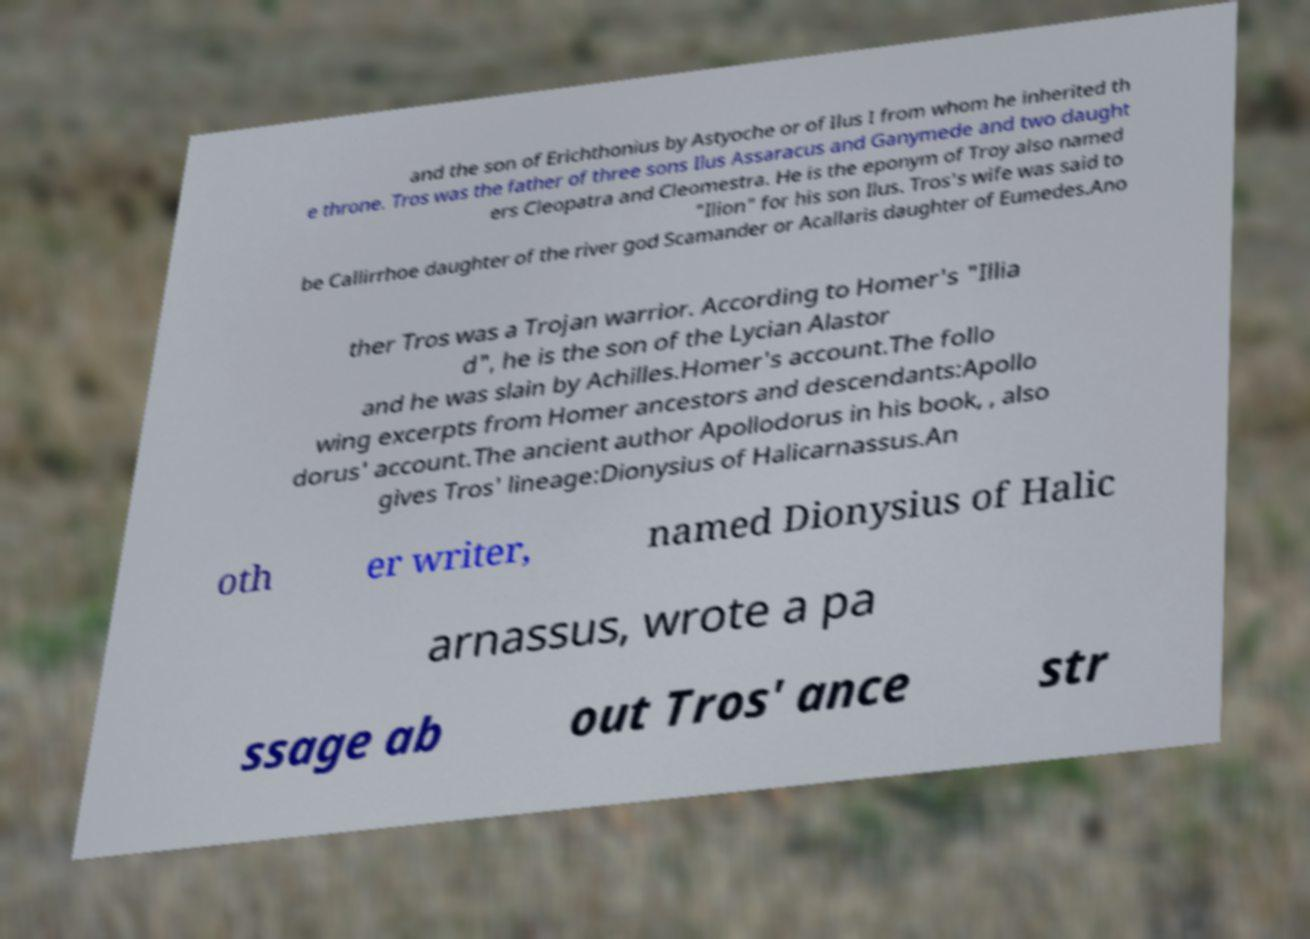Please read and relay the text visible in this image. What does it say? and the son of Erichthonius by Astyoche or of Ilus I from whom he inherited th e throne. Tros was the father of three sons Ilus Assaracus and Ganymede and two daught ers Cleopatra and Cleomestra. He is the eponym of Troy also named "Ilion" for his son Ilus. Tros's wife was said to be Callirrhoe daughter of the river god Scamander or Acallaris daughter of Eumedes.Ano ther Tros was a Trojan warrior. According to Homer's "Illia d", he is the son of the Lycian Alastor and he was slain by Achilles.Homer's account.The follo wing excerpts from Homer ancestors and descendants:Apollo dorus' account.The ancient author Apollodorus in his book, , also gives Tros' lineage:Dionysius of Halicarnassus.An oth er writer, named Dionysius of Halic arnassus, wrote a pa ssage ab out Tros' ance str 